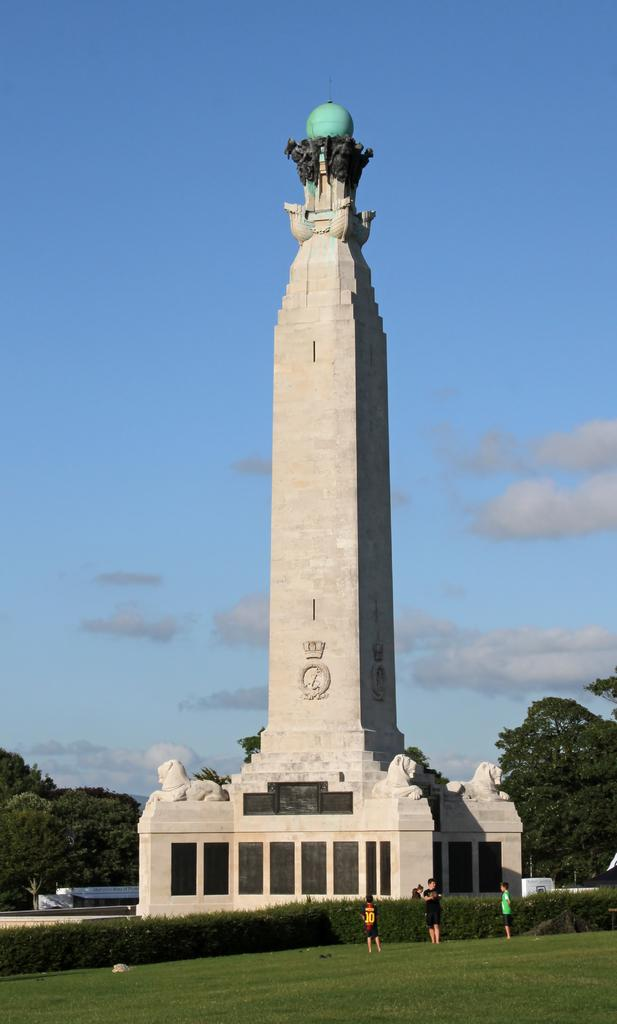What type of vegetation can be seen in the image? There is grass and plants in the image. How many people are present in the image? Four people are standing in the image. What structure is visible in the image? There is a tower in the image. What other natural elements can be seen in the image? There are trees in the image. What else is present in the image besides the people and structures? There are some objects in the image. What is visible in the background of the image? The sky is visible in the background of the image. What can be observed in the sky? Clouds are present in the sky. What type of question is being asked in the image? There is no question being asked in the image; it is a visual representation of a scene. What activity are the people engaged in within the image? The image does not show the people engaged in any specific activity; they are simply standing. Is there a twist in the image? There is no twist or unexpected element in the image; it is a straightforward representation of a scene with people, structures, and natural elements. 